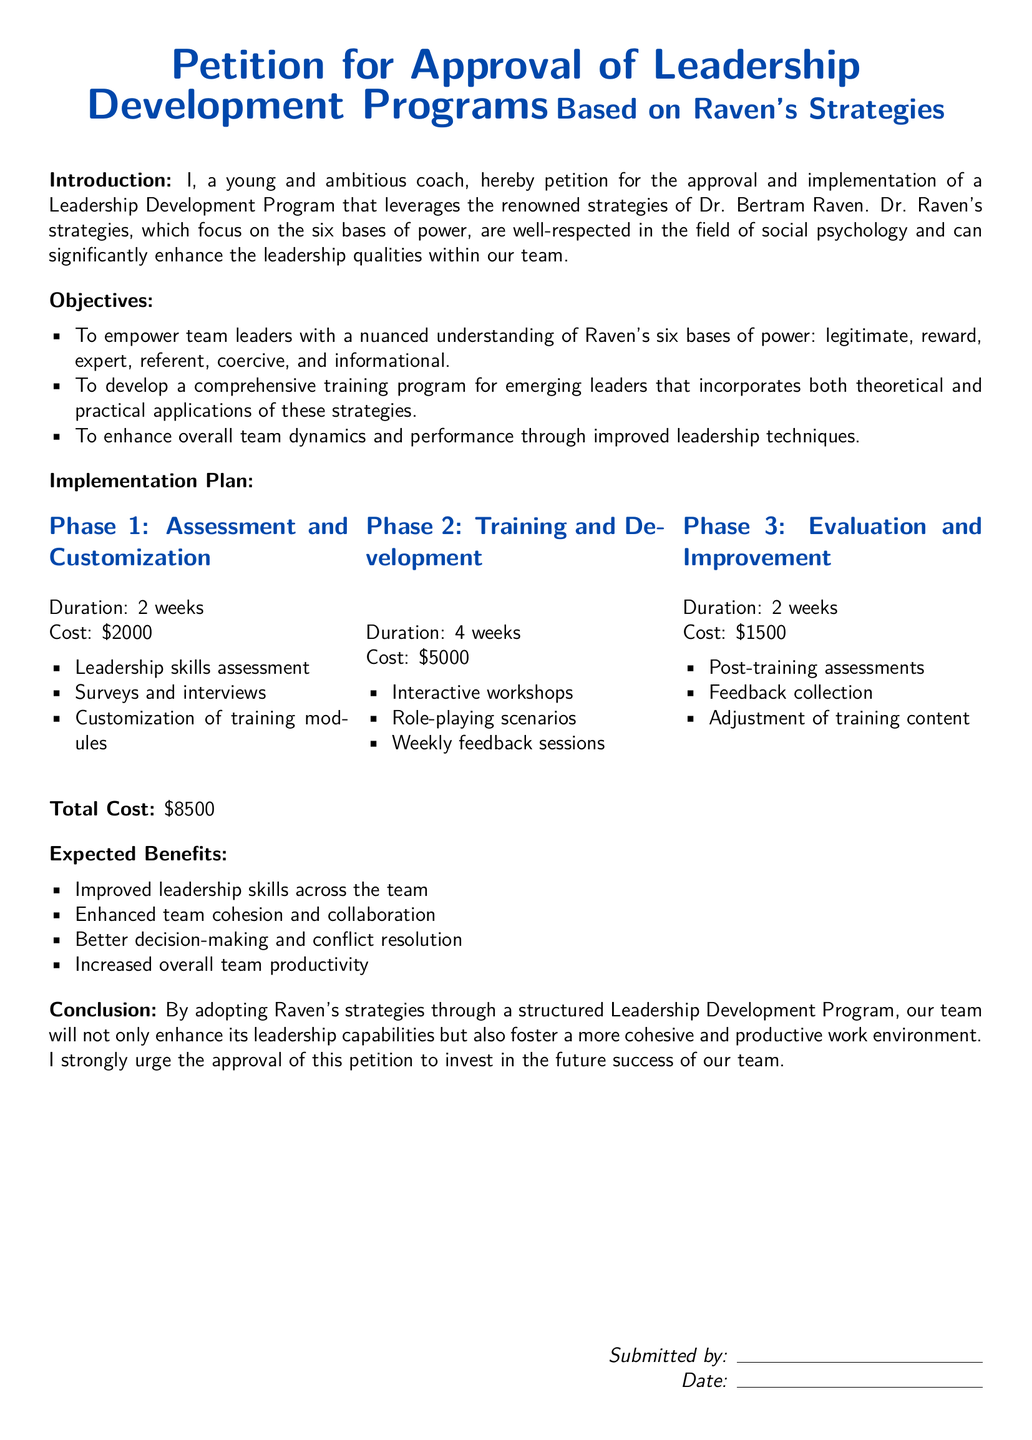What is the total cost of the program? The total cost is explicitly stated in the document as the sum of all costs incurred across phases.
Answer: $8500 How long will the Assessment and Customization phase last? The document specifies the duration of this phase as part of the implementation plan.
Answer: 2 weeks What are the six bases of power according to Raven? The document outlines the six bases of power that will be covered in the training program.
Answer: legitimate, reward, expert, referent, coercive, informational What is the purpose of the weekly feedback sessions? Weekly feedback sessions are noted in the training and development phase, aiming to support learning and improvement.
Answer: Support learning and improvement How many phases are outlined in the implementation plan? The document clearly delineates the structure of the implementation plan into distinct phases.
Answer: 3 phases What is the expected outcome related to team productivity? The document lists one of the benefits as an increase in overall team productivity, signifying expected improvements.
Answer: Increased overall team productivity What is the main theme of the petition? The petition focuses on implementing a leadership development program based on specific psychological strategies.
Answer: Leadership Development Programs What will happen during the Evaluation and Improvement phase? This phase involves assessing the effectiveness of the training through feedback and adjustments, as detailed in the document.
Answer: Post-training assessments and adjustments What is the duration of the Training and Development phase? The document specifies the length of this phase as part of the structured plan for implementation.
Answer: 4 weeks 